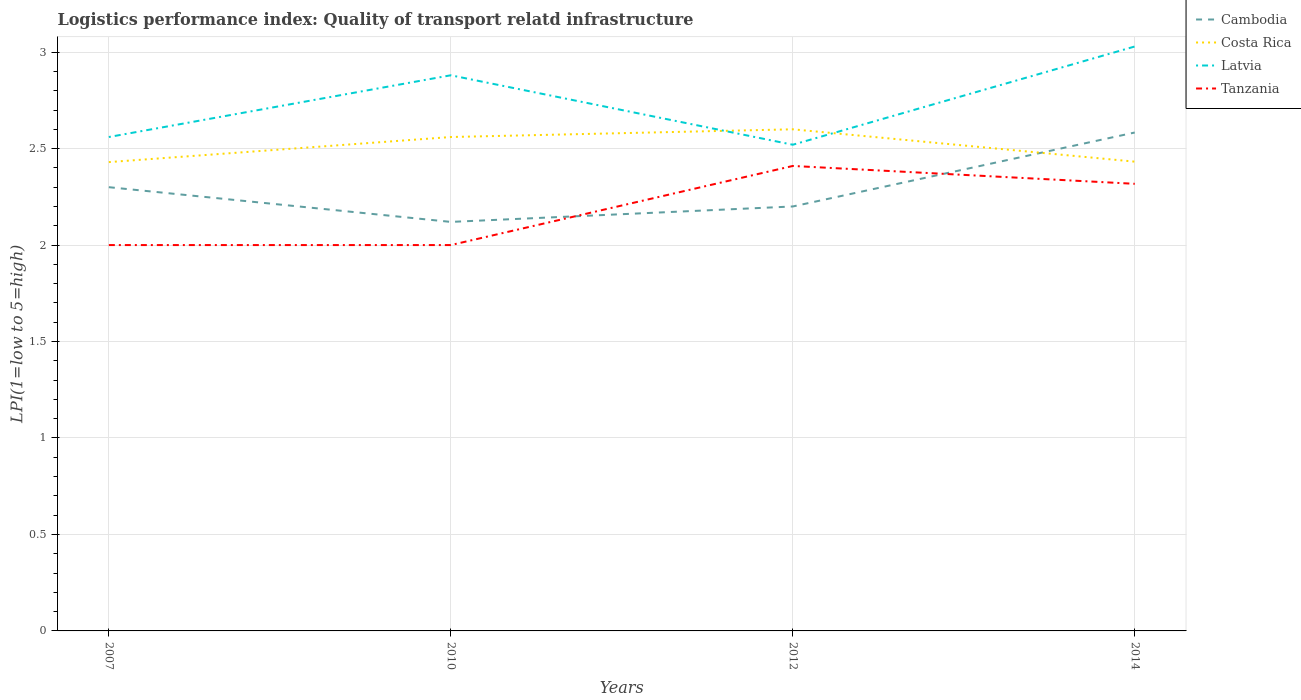Does the line corresponding to Cambodia intersect with the line corresponding to Tanzania?
Make the answer very short. Yes. Is the number of lines equal to the number of legend labels?
Offer a very short reply. Yes. Across all years, what is the maximum logistics performance index in Costa Rica?
Your response must be concise. 2.43. What is the total logistics performance index in Costa Rica in the graph?
Your response must be concise. 0.17. What is the difference between the highest and the second highest logistics performance index in Latvia?
Give a very brief answer. 0.51. Is the logistics performance index in Tanzania strictly greater than the logistics performance index in Costa Rica over the years?
Provide a succinct answer. Yes. How many years are there in the graph?
Provide a short and direct response. 4. What is the difference between two consecutive major ticks on the Y-axis?
Offer a very short reply. 0.5. Are the values on the major ticks of Y-axis written in scientific E-notation?
Give a very brief answer. No. Does the graph contain any zero values?
Your response must be concise. No. What is the title of the graph?
Make the answer very short. Logistics performance index: Quality of transport relatd infrastructure. What is the label or title of the X-axis?
Give a very brief answer. Years. What is the label or title of the Y-axis?
Provide a succinct answer. LPI(1=low to 5=high). What is the LPI(1=low to 5=high) of Costa Rica in 2007?
Give a very brief answer. 2.43. What is the LPI(1=low to 5=high) in Latvia in 2007?
Give a very brief answer. 2.56. What is the LPI(1=low to 5=high) of Cambodia in 2010?
Offer a terse response. 2.12. What is the LPI(1=low to 5=high) in Costa Rica in 2010?
Your answer should be compact. 2.56. What is the LPI(1=low to 5=high) in Latvia in 2010?
Provide a short and direct response. 2.88. What is the LPI(1=low to 5=high) of Tanzania in 2010?
Provide a succinct answer. 2. What is the LPI(1=low to 5=high) in Costa Rica in 2012?
Give a very brief answer. 2.6. What is the LPI(1=low to 5=high) in Latvia in 2012?
Provide a short and direct response. 2.52. What is the LPI(1=low to 5=high) of Tanzania in 2012?
Your answer should be compact. 2.41. What is the LPI(1=low to 5=high) in Cambodia in 2014?
Your answer should be compact. 2.58. What is the LPI(1=low to 5=high) of Costa Rica in 2014?
Your answer should be very brief. 2.43. What is the LPI(1=low to 5=high) of Latvia in 2014?
Provide a succinct answer. 3.03. What is the LPI(1=low to 5=high) of Tanzania in 2014?
Offer a terse response. 2.32. Across all years, what is the maximum LPI(1=low to 5=high) of Cambodia?
Your answer should be very brief. 2.58. Across all years, what is the maximum LPI(1=low to 5=high) of Latvia?
Make the answer very short. 3.03. Across all years, what is the maximum LPI(1=low to 5=high) in Tanzania?
Your answer should be compact. 2.41. Across all years, what is the minimum LPI(1=low to 5=high) of Cambodia?
Offer a terse response. 2.12. Across all years, what is the minimum LPI(1=low to 5=high) in Costa Rica?
Keep it short and to the point. 2.43. Across all years, what is the minimum LPI(1=low to 5=high) in Latvia?
Provide a short and direct response. 2.52. What is the total LPI(1=low to 5=high) of Cambodia in the graph?
Your answer should be compact. 9.2. What is the total LPI(1=low to 5=high) of Costa Rica in the graph?
Your response must be concise. 10.02. What is the total LPI(1=low to 5=high) of Latvia in the graph?
Give a very brief answer. 10.99. What is the total LPI(1=low to 5=high) in Tanzania in the graph?
Make the answer very short. 8.73. What is the difference between the LPI(1=low to 5=high) in Cambodia in 2007 and that in 2010?
Your answer should be compact. 0.18. What is the difference between the LPI(1=low to 5=high) of Costa Rica in 2007 and that in 2010?
Ensure brevity in your answer.  -0.13. What is the difference between the LPI(1=low to 5=high) in Latvia in 2007 and that in 2010?
Your answer should be very brief. -0.32. What is the difference between the LPI(1=low to 5=high) in Tanzania in 2007 and that in 2010?
Your response must be concise. 0. What is the difference between the LPI(1=low to 5=high) in Costa Rica in 2007 and that in 2012?
Provide a succinct answer. -0.17. What is the difference between the LPI(1=low to 5=high) of Latvia in 2007 and that in 2012?
Your answer should be very brief. 0.04. What is the difference between the LPI(1=low to 5=high) of Tanzania in 2007 and that in 2012?
Ensure brevity in your answer.  -0.41. What is the difference between the LPI(1=low to 5=high) of Cambodia in 2007 and that in 2014?
Offer a terse response. -0.28. What is the difference between the LPI(1=low to 5=high) of Costa Rica in 2007 and that in 2014?
Your answer should be very brief. -0. What is the difference between the LPI(1=low to 5=high) in Latvia in 2007 and that in 2014?
Offer a terse response. -0.47. What is the difference between the LPI(1=low to 5=high) in Tanzania in 2007 and that in 2014?
Offer a very short reply. -0.32. What is the difference between the LPI(1=low to 5=high) in Cambodia in 2010 and that in 2012?
Your response must be concise. -0.08. What is the difference between the LPI(1=low to 5=high) of Costa Rica in 2010 and that in 2012?
Your answer should be compact. -0.04. What is the difference between the LPI(1=low to 5=high) of Latvia in 2010 and that in 2012?
Your answer should be very brief. 0.36. What is the difference between the LPI(1=low to 5=high) in Tanzania in 2010 and that in 2012?
Offer a very short reply. -0.41. What is the difference between the LPI(1=low to 5=high) of Cambodia in 2010 and that in 2014?
Provide a short and direct response. -0.46. What is the difference between the LPI(1=low to 5=high) of Costa Rica in 2010 and that in 2014?
Your answer should be very brief. 0.13. What is the difference between the LPI(1=low to 5=high) in Latvia in 2010 and that in 2014?
Make the answer very short. -0.15. What is the difference between the LPI(1=low to 5=high) of Tanzania in 2010 and that in 2014?
Your answer should be very brief. -0.32. What is the difference between the LPI(1=low to 5=high) in Cambodia in 2012 and that in 2014?
Offer a terse response. -0.38. What is the difference between the LPI(1=low to 5=high) of Costa Rica in 2012 and that in 2014?
Provide a succinct answer. 0.17. What is the difference between the LPI(1=low to 5=high) in Latvia in 2012 and that in 2014?
Provide a short and direct response. -0.51. What is the difference between the LPI(1=low to 5=high) in Tanzania in 2012 and that in 2014?
Make the answer very short. 0.09. What is the difference between the LPI(1=low to 5=high) in Cambodia in 2007 and the LPI(1=low to 5=high) in Costa Rica in 2010?
Keep it short and to the point. -0.26. What is the difference between the LPI(1=low to 5=high) in Cambodia in 2007 and the LPI(1=low to 5=high) in Latvia in 2010?
Provide a succinct answer. -0.58. What is the difference between the LPI(1=low to 5=high) in Costa Rica in 2007 and the LPI(1=low to 5=high) in Latvia in 2010?
Offer a very short reply. -0.45. What is the difference between the LPI(1=low to 5=high) in Costa Rica in 2007 and the LPI(1=low to 5=high) in Tanzania in 2010?
Offer a terse response. 0.43. What is the difference between the LPI(1=low to 5=high) in Latvia in 2007 and the LPI(1=low to 5=high) in Tanzania in 2010?
Your answer should be very brief. 0.56. What is the difference between the LPI(1=low to 5=high) of Cambodia in 2007 and the LPI(1=low to 5=high) of Costa Rica in 2012?
Your response must be concise. -0.3. What is the difference between the LPI(1=low to 5=high) in Cambodia in 2007 and the LPI(1=low to 5=high) in Latvia in 2012?
Offer a terse response. -0.22. What is the difference between the LPI(1=low to 5=high) in Cambodia in 2007 and the LPI(1=low to 5=high) in Tanzania in 2012?
Give a very brief answer. -0.11. What is the difference between the LPI(1=low to 5=high) of Costa Rica in 2007 and the LPI(1=low to 5=high) of Latvia in 2012?
Offer a terse response. -0.09. What is the difference between the LPI(1=low to 5=high) of Cambodia in 2007 and the LPI(1=low to 5=high) of Costa Rica in 2014?
Offer a very short reply. -0.13. What is the difference between the LPI(1=low to 5=high) in Cambodia in 2007 and the LPI(1=low to 5=high) in Latvia in 2014?
Provide a succinct answer. -0.73. What is the difference between the LPI(1=low to 5=high) in Cambodia in 2007 and the LPI(1=low to 5=high) in Tanzania in 2014?
Your answer should be compact. -0.02. What is the difference between the LPI(1=low to 5=high) in Costa Rica in 2007 and the LPI(1=low to 5=high) in Latvia in 2014?
Keep it short and to the point. -0.6. What is the difference between the LPI(1=low to 5=high) of Costa Rica in 2007 and the LPI(1=low to 5=high) of Tanzania in 2014?
Your answer should be very brief. 0.11. What is the difference between the LPI(1=low to 5=high) of Latvia in 2007 and the LPI(1=low to 5=high) of Tanzania in 2014?
Make the answer very short. 0.24. What is the difference between the LPI(1=low to 5=high) in Cambodia in 2010 and the LPI(1=low to 5=high) in Costa Rica in 2012?
Keep it short and to the point. -0.48. What is the difference between the LPI(1=low to 5=high) of Cambodia in 2010 and the LPI(1=low to 5=high) of Tanzania in 2012?
Your answer should be very brief. -0.29. What is the difference between the LPI(1=low to 5=high) in Costa Rica in 2010 and the LPI(1=low to 5=high) in Tanzania in 2012?
Offer a terse response. 0.15. What is the difference between the LPI(1=low to 5=high) of Latvia in 2010 and the LPI(1=low to 5=high) of Tanzania in 2012?
Make the answer very short. 0.47. What is the difference between the LPI(1=low to 5=high) of Cambodia in 2010 and the LPI(1=low to 5=high) of Costa Rica in 2014?
Offer a terse response. -0.31. What is the difference between the LPI(1=low to 5=high) in Cambodia in 2010 and the LPI(1=low to 5=high) in Latvia in 2014?
Provide a short and direct response. -0.91. What is the difference between the LPI(1=low to 5=high) of Cambodia in 2010 and the LPI(1=low to 5=high) of Tanzania in 2014?
Provide a short and direct response. -0.2. What is the difference between the LPI(1=low to 5=high) of Costa Rica in 2010 and the LPI(1=low to 5=high) of Latvia in 2014?
Make the answer very short. -0.47. What is the difference between the LPI(1=low to 5=high) of Costa Rica in 2010 and the LPI(1=low to 5=high) of Tanzania in 2014?
Give a very brief answer. 0.24. What is the difference between the LPI(1=low to 5=high) in Latvia in 2010 and the LPI(1=low to 5=high) in Tanzania in 2014?
Your answer should be very brief. 0.56. What is the difference between the LPI(1=low to 5=high) of Cambodia in 2012 and the LPI(1=low to 5=high) of Costa Rica in 2014?
Offer a very short reply. -0.23. What is the difference between the LPI(1=low to 5=high) of Cambodia in 2012 and the LPI(1=low to 5=high) of Latvia in 2014?
Provide a short and direct response. -0.83. What is the difference between the LPI(1=low to 5=high) of Cambodia in 2012 and the LPI(1=low to 5=high) of Tanzania in 2014?
Offer a very short reply. -0.12. What is the difference between the LPI(1=low to 5=high) in Costa Rica in 2012 and the LPI(1=low to 5=high) in Latvia in 2014?
Make the answer very short. -0.43. What is the difference between the LPI(1=low to 5=high) of Costa Rica in 2012 and the LPI(1=low to 5=high) of Tanzania in 2014?
Offer a very short reply. 0.28. What is the difference between the LPI(1=low to 5=high) of Latvia in 2012 and the LPI(1=low to 5=high) of Tanzania in 2014?
Your answer should be very brief. 0.2. What is the average LPI(1=low to 5=high) in Cambodia per year?
Your answer should be compact. 2.3. What is the average LPI(1=low to 5=high) in Costa Rica per year?
Provide a short and direct response. 2.51. What is the average LPI(1=low to 5=high) of Latvia per year?
Your answer should be compact. 2.75. What is the average LPI(1=low to 5=high) in Tanzania per year?
Your response must be concise. 2.18. In the year 2007, what is the difference between the LPI(1=low to 5=high) of Cambodia and LPI(1=low to 5=high) of Costa Rica?
Your answer should be very brief. -0.13. In the year 2007, what is the difference between the LPI(1=low to 5=high) in Cambodia and LPI(1=low to 5=high) in Latvia?
Offer a very short reply. -0.26. In the year 2007, what is the difference between the LPI(1=low to 5=high) of Costa Rica and LPI(1=low to 5=high) of Latvia?
Your answer should be very brief. -0.13. In the year 2007, what is the difference between the LPI(1=low to 5=high) of Costa Rica and LPI(1=low to 5=high) of Tanzania?
Your answer should be compact. 0.43. In the year 2007, what is the difference between the LPI(1=low to 5=high) of Latvia and LPI(1=low to 5=high) of Tanzania?
Ensure brevity in your answer.  0.56. In the year 2010, what is the difference between the LPI(1=low to 5=high) in Cambodia and LPI(1=low to 5=high) in Costa Rica?
Your answer should be compact. -0.44. In the year 2010, what is the difference between the LPI(1=low to 5=high) in Cambodia and LPI(1=low to 5=high) in Latvia?
Your answer should be compact. -0.76. In the year 2010, what is the difference between the LPI(1=low to 5=high) in Cambodia and LPI(1=low to 5=high) in Tanzania?
Give a very brief answer. 0.12. In the year 2010, what is the difference between the LPI(1=low to 5=high) of Costa Rica and LPI(1=low to 5=high) of Latvia?
Your response must be concise. -0.32. In the year 2010, what is the difference between the LPI(1=low to 5=high) of Costa Rica and LPI(1=low to 5=high) of Tanzania?
Give a very brief answer. 0.56. In the year 2012, what is the difference between the LPI(1=low to 5=high) of Cambodia and LPI(1=low to 5=high) of Latvia?
Ensure brevity in your answer.  -0.32. In the year 2012, what is the difference between the LPI(1=low to 5=high) of Cambodia and LPI(1=low to 5=high) of Tanzania?
Make the answer very short. -0.21. In the year 2012, what is the difference between the LPI(1=low to 5=high) in Costa Rica and LPI(1=low to 5=high) in Latvia?
Your answer should be compact. 0.08. In the year 2012, what is the difference between the LPI(1=low to 5=high) in Costa Rica and LPI(1=low to 5=high) in Tanzania?
Provide a short and direct response. 0.19. In the year 2012, what is the difference between the LPI(1=low to 5=high) in Latvia and LPI(1=low to 5=high) in Tanzania?
Your answer should be very brief. 0.11. In the year 2014, what is the difference between the LPI(1=low to 5=high) of Cambodia and LPI(1=low to 5=high) of Costa Rica?
Offer a very short reply. 0.15. In the year 2014, what is the difference between the LPI(1=low to 5=high) in Cambodia and LPI(1=low to 5=high) in Latvia?
Ensure brevity in your answer.  -0.45. In the year 2014, what is the difference between the LPI(1=low to 5=high) in Cambodia and LPI(1=low to 5=high) in Tanzania?
Ensure brevity in your answer.  0.27. In the year 2014, what is the difference between the LPI(1=low to 5=high) in Costa Rica and LPI(1=low to 5=high) in Latvia?
Provide a succinct answer. -0.6. In the year 2014, what is the difference between the LPI(1=low to 5=high) of Costa Rica and LPI(1=low to 5=high) of Tanzania?
Make the answer very short. 0.11. In the year 2014, what is the difference between the LPI(1=low to 5=high) in Latvia and LPI(1=low to 5=high) in Tanzania?
Your response must be concise. 0.71. What is the ratio of the LPI(1=low to 5=high) in Cambodia in 2007 to that in 2010?
Ensure brevity in your answer.  1.08. What is the ratio of the LPI(1=low to 5=high) of Costa Rica in 2007 to that in 2010?
Ensure brevity in your answer.  0.95. What is the ratio of the LPI(1=low to 5=high) of Cambodia in 2007 to that in 2012?
Ensure brevity in your answer.  1.05. What is the ratio of the LPI(1=low to 5=high) of Costa Rica in 2007 to that in 2012?
Offer a terse response. 0.93. What is the ratio of the LPI(1=low to 5=high) in Latvia in 2007 to that in 2012?
Ensure brevity in your answer.  1.02. What is the ratio of the LPI(1=low to 5=high) in Tanzania in 2007 to that in 2012?
Give a very brief answer. 0.83. What is the ratio of the LPI(1=low to 5=high) in Cambodia in 2007 to that in 2014?
Keep it short and to the point. 0.89. What is the ratio of the LPI(1=low to 5=high) of Costa Rica in 2007 to that in 2014?
Your answer should be compact. 1. What is the ratio of the LPI(1=low to 5=high) in Latvia in 2007 to that in 2014?
Give a very brief answer. 0.85. What is the ratio of the LPI(1=low to 5=high) of Tanzania in 2007 to that in 2014?
Your answer should be very brief. 0.86. What is the ratio of the LPI(1=low to 5=high) in Cambodia in 2010 to that in 2012?
Offer a terse response. 0.96. What is the ratio of the LPI(1=low to 5=high) of Costa Rica in 2010 to that in 2012?
Ensure brevity in your answer.  0.98. What is the ratio of the LPI(1=low to 5=high) in Latvia in 2010 to that in 2012?
Provide a short and direct response. 1.14. What is the ratio of the LPI(1=low to 5=high) in Tanzania in 2010 to that in 2012?
Provide a succinct answer. 0.83. What is the ratio of the LPI(1=low to 5=high) of Cambodia in 2010 to that in 2014?
Provide a short and direct response. 0.82. What is the ratio of the LPI(1=low to 5=high) of Costa Rica in 2010 to that in 2014?
Your response must be concise. 1.05. What is the ratio of the LPI(1=low to 5=high) of Latvia in 2010 to that in 2014?
Your answer should be compact. 0.95. What is the ratio of the LPI(1=low to 5=high) of Tanzania in 2010 to that in 2014?
Your answer should be compact. 0.86. What is the ratio of the LPI(1=low to 5=high) of Cambodia in 2012 to that in 2014?
Keep it short and to the point. 0.85. What is the ratio of the LPI(1=low to 5=high) of Costa Rica in 2012 to that in 2014?
Provide a short and direct response. 1.07. What is the ratio of the LPI(1=low to 5=high) of Latvia in 2012 to that in 2014?
Provide a short and direct response. 0.83. What is the ratio of the LPI(1=low to 5=high) of Tanzania in 2012 to that in 2014?
Make the answer very short. 1.04. What is the difference between the highest and the second highest LPI(1=low to 5=high) in Cambodia?
Ensure brevity in your answer.  0.28. What is the difference between the highest and the second highest LPI(1=low to 5=high) of Latvia?
Provide a succinct answer. 0.15. What is the difference between the highest and the second highest LPI(1=low to 5=high) in Tanzania?
Your response must be concise. 0.09. What is the difference between the highest and the lowest LPI(1=low to 5=high) in Cambodia?
Make the answer very short. 0.46. What is the difference between the highest and the lowest LPI(1=low to 5=high) of Costa Rica?
Ensure brevity in your answer.  0.17. What is the difference between the highest and the lowest LPI(1=low to 5=high) in Latvia?
Your answer should be very brief. 0.51. What is the difference between the highest and the lowest LPI(1=low to 5=high) of Tanzania?
Keep it short and to the point. 0.41. 